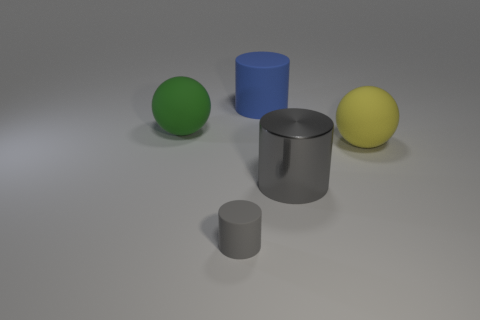Is there anything else that is the same size as the gray rubber cylinder?
Ensure brevity in your answer.  No. Do the yellow rubber object and the matte cylinder in front of the large yellow matte sphere have the same size?
Give a very brief answer. No. What is the size of the other cylinder that is the same color as the small cylinder?
Keep it short and to the point. Large. Is the number of matte things greater than the number of large gray things?
Provide a short and direct response. Yes. Do the green thing and the tiny gray cylinder have the same material?
Provide a succinct answer. Yes. What number of rubber things are either green balls or blue cubes?
Your answer should be very brief. 1. What color is the other cylinder that is the same size as the blue cylinder?
Make the answer very short. Gray. What number of other big things have the same shape as the large gray metallic object?
Your answer should be very brief. 1. How many cylinders are either large green things or tiny matte things?
Provide a succinct answer. 1. There is a big object that is on the left side of the blue cylinder; does it have the same shape as the gray thing right of the tiny matte object?
Your response must be concise. No. 